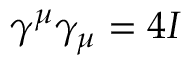Convert formula to latex. <formula><loc_0><loc_0><loc_500><loc_500>\gamma ^ { \mu } \gamma _ { \mu } = 4 I</formula> 